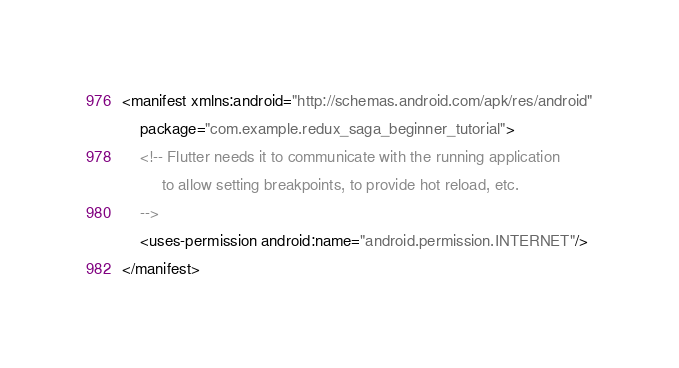Convert code to text. <code><loc_0><loc_0><loc_500><loc_500><_XML_><manifest xmlns:android="http://schemas.android.com/apk/res/android"
    package="com.example.redux_saga_beginner_tutorial">
    <!-- Flutter needs it to communicate with the running application
         to allow setting breakpoints, to provide hot reload, etc.
    -->
    <uses-permission android:name="android.permission.INTERNET"/>
</manifest>
</code> 